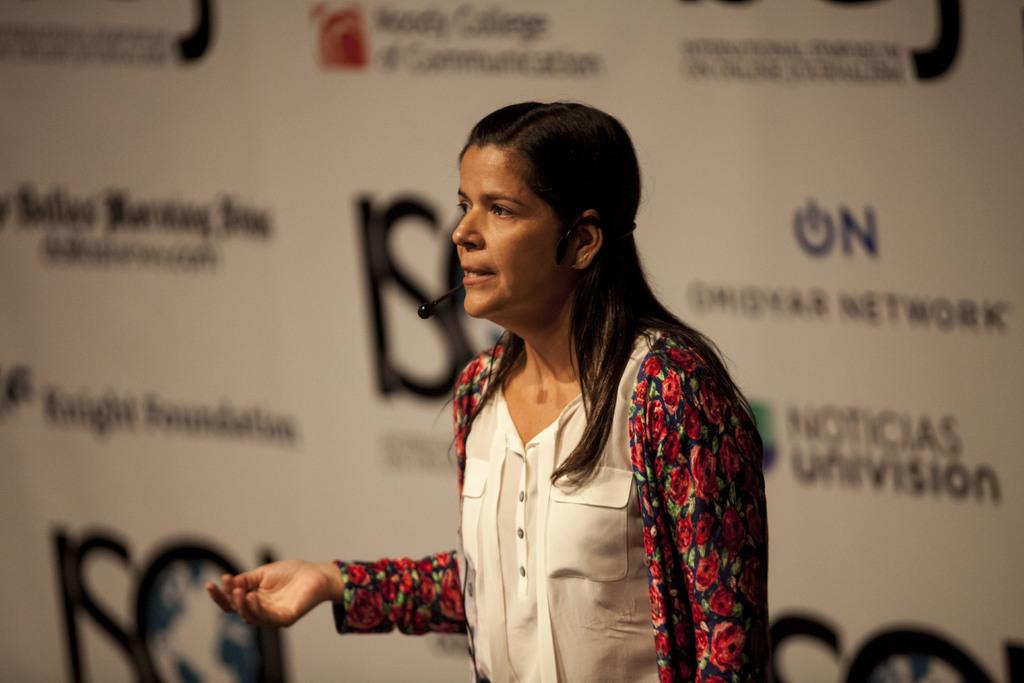What is the main subject of the image? The main subject of the image is a woman. What is the woman doing in the image? The woman is standing and talking in the image. What is the woman wearing that is related to her activity? The woman is wearing a microphone. What can be seen in the background of the image? There is a banner in the background of the image. What type of sail can be seen in the image? There is no sail present in the image. What does the woman's voice sound like in the image? The image is a still photograph, so it does not capture the sound of the woman's voice. 